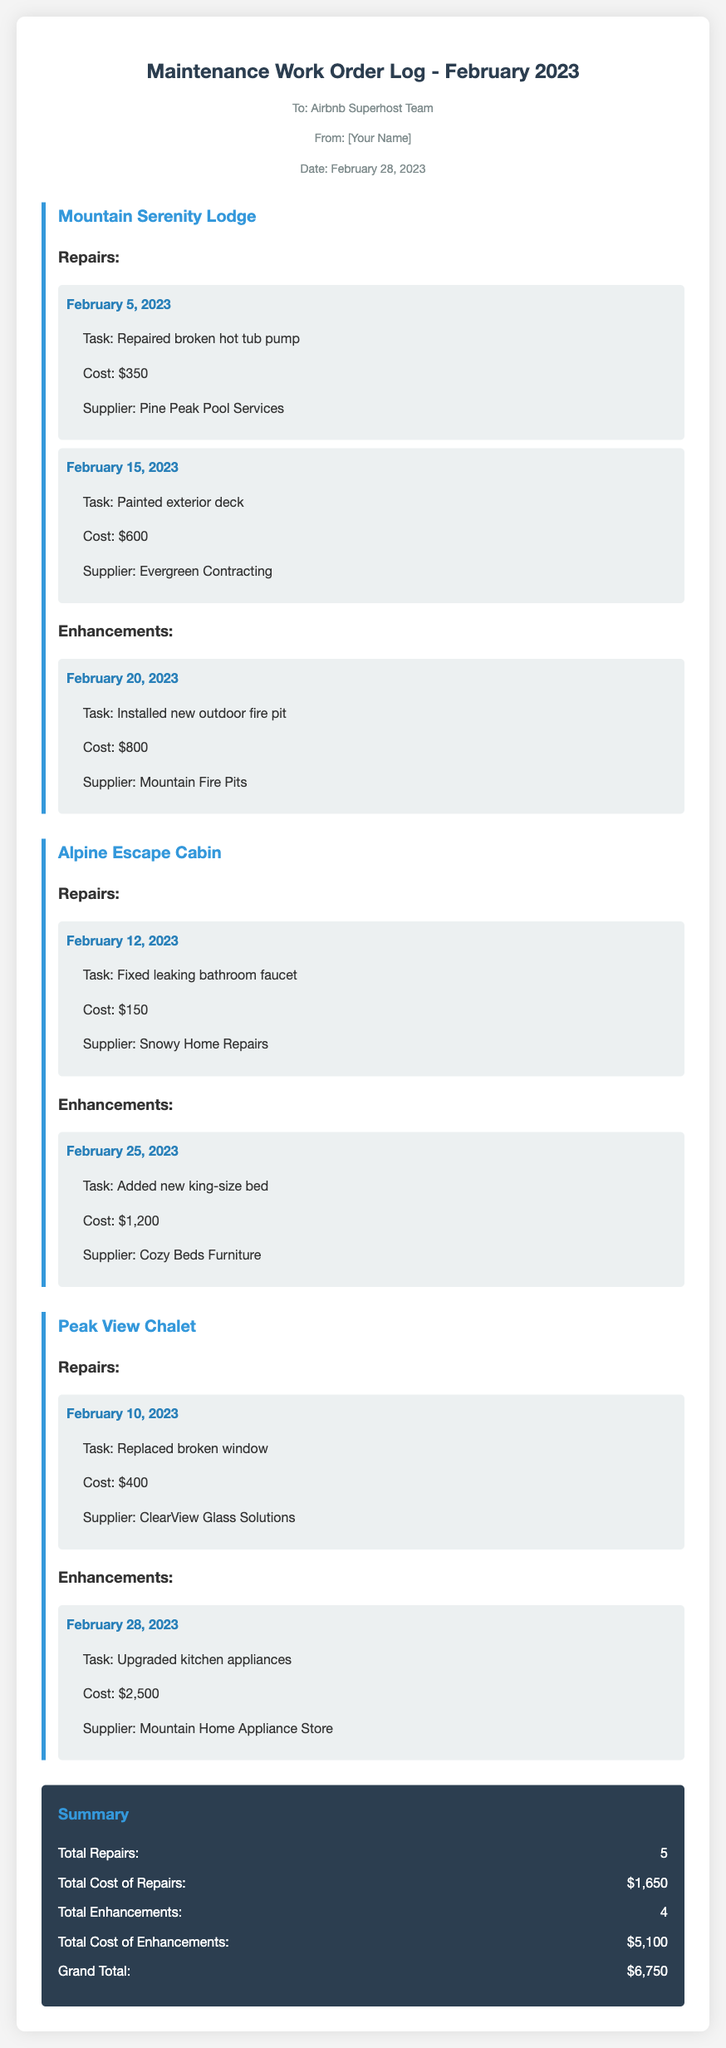What is the date of the memo? The memo is dated February 28, 2023, as indicated at the top of the document.
Answer: February 28, 2023 How many repairs were recorded in February 2023? The document lists a total of 5 repairs across all properties.
Answer: 5 What was the cost to paint the exterior deck at Mountain Serenity Lodge? The cost for painting the exterior deck is stated as $600.
Answer: $600 Which property had a king-size bed added? The memo specifies that a king-size bed was added to Alpine Escape Cabin.
Answer: Alpine Escape Cabin What is the total cost of enhancements for February 2023? The total cost of enhancements, which is calculated in the summary, is $5,100.
Answer: $5,100 Which supplier was used for the installation of the new outdoor fire pit? The document mentions Mountain Fire Pits as the supplier for the new outdoor fire pit.
Answer: Mountain Fire Pits What type of repair was made on February 12, 2023? A leaking bathroom faucet was fixed on February 12, 2023, in Alpine Escape Cabin.
Answer: Fixed leaking bathroom faucet What was the grand total for repairs and enhancements? The grand total combines the cost of both repairs and enhancements, totaling $6,750.
Answer: $6,750 What enhancement was made at Peak View Chalet on February 28, 2023? The document indicates that kitchen appliances were upgraded at Peak View Chalet.
Answer: Upgraded kitchen appliances 